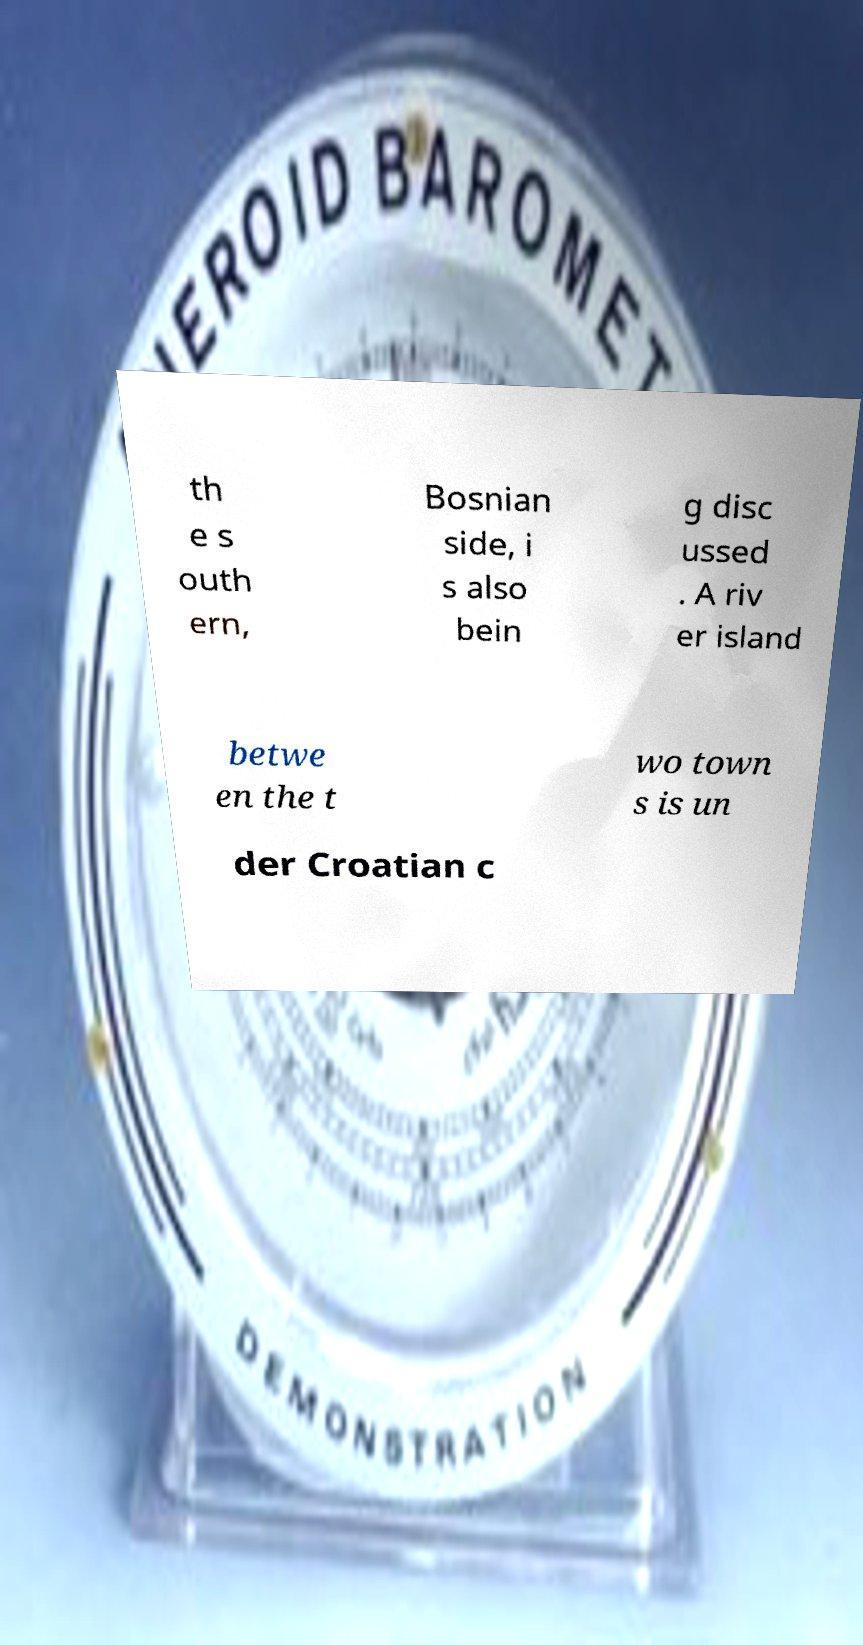Please read and relay the text visible in this image. What does it say? th e s outh ern, Bosnian side, i s also bein g disc ussed . A riv er island betwe en the t wo town s is un der Croatian c 